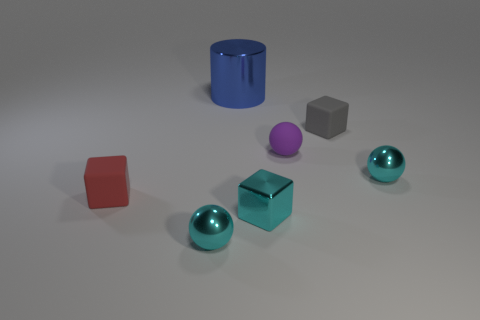Add 3 gray matte objects. How many objects exist? 10 Subtract all cubes. How many objects are left? 4 Subtract all tiny gray blocks. Subtract all blue shiny things. How many objects are left? 5 Add 6 purple matte objects. How many purple matte objects are left? 7 Add 6 small metal cylinders. How many small metal cylinders exist? 6 Subtract 0 yellow cylinders. How many objects are left? 7 